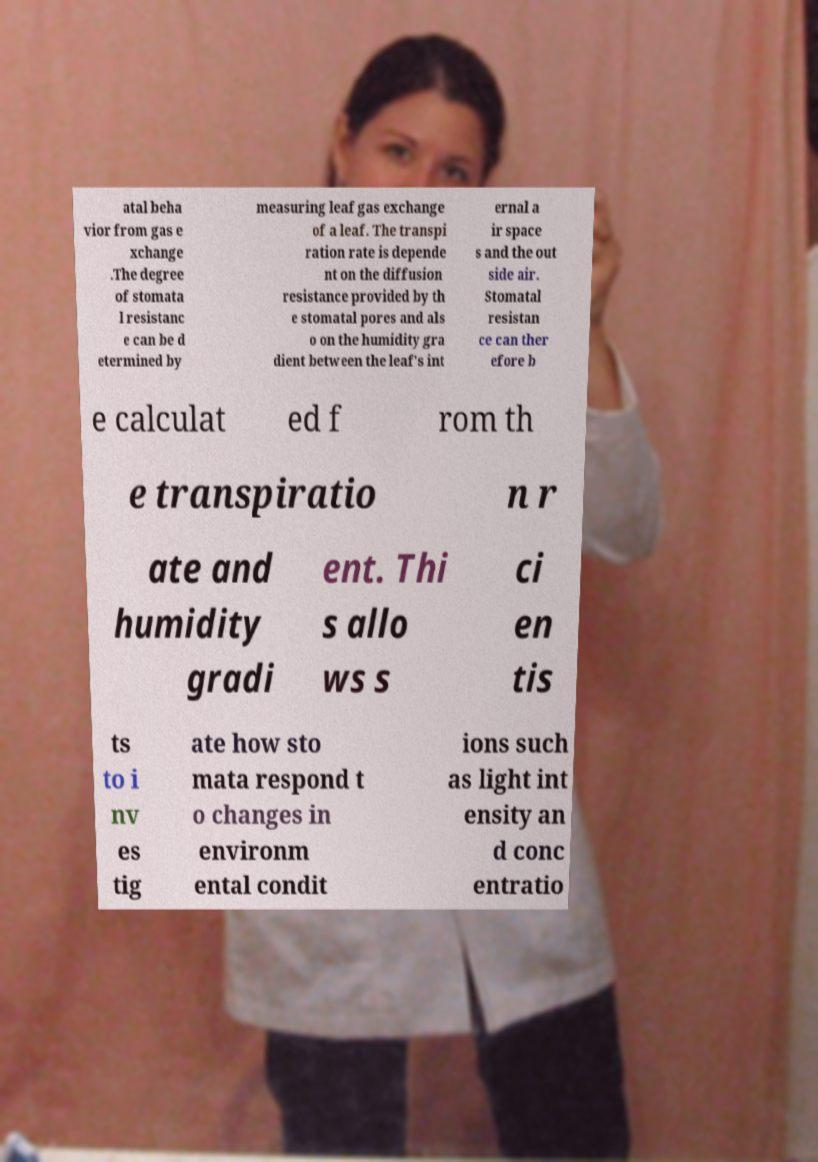Please identify and transcribe the text found in this image. atal beha vior from gas e xchange .The degree of stomata l resistanc e can be d etermined by measuring leaf gas exchange of a leaf. The transpi ration rate is depende nt on the diffusion resistance provided by th e stomatal pores and als o on the humidity gra dient between the leaf's int ernal a ir space s and the out side air. Stomatal resistan ce can ther efore b e calculat ed f rom th e transpiratio n r ate and humidity gradi ent. Thi s allo ws s ci en tis ts to i nv es tig ate how sto mata respond t o changes in environm ental condit ions such as light int ensity an d conc entratio 